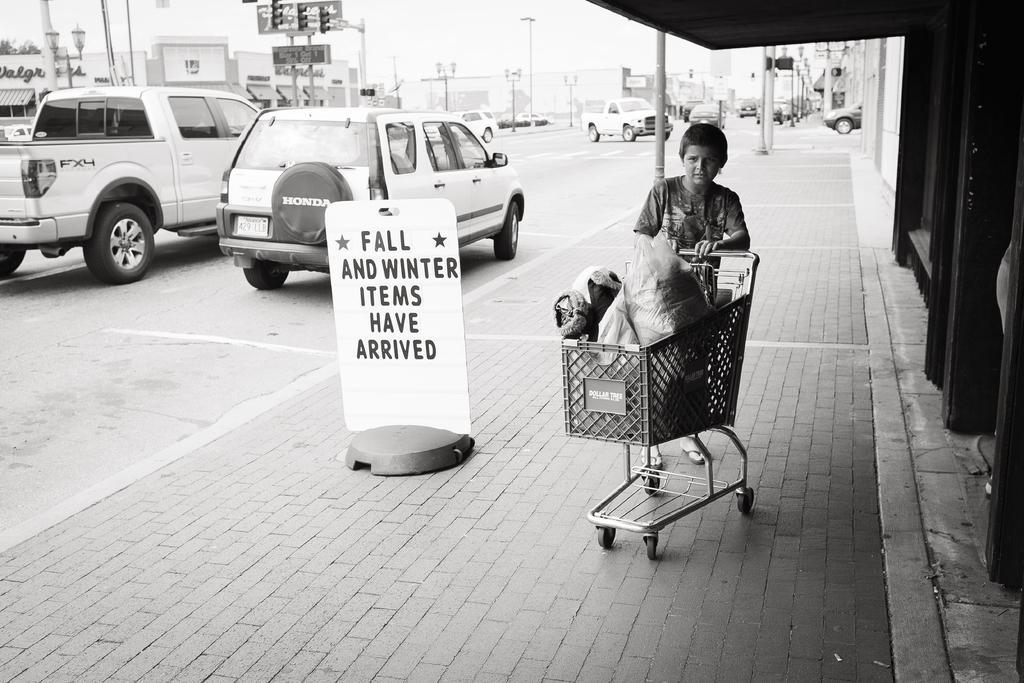In one or two sentences, can you explain what this image depicts? There is a boy holding a trolley in which, there are some objects on the footpath. On the right side, there is a building. On the left side, there are vehicles on the road. In the background, there are poles, there are buildings and there is sky. 